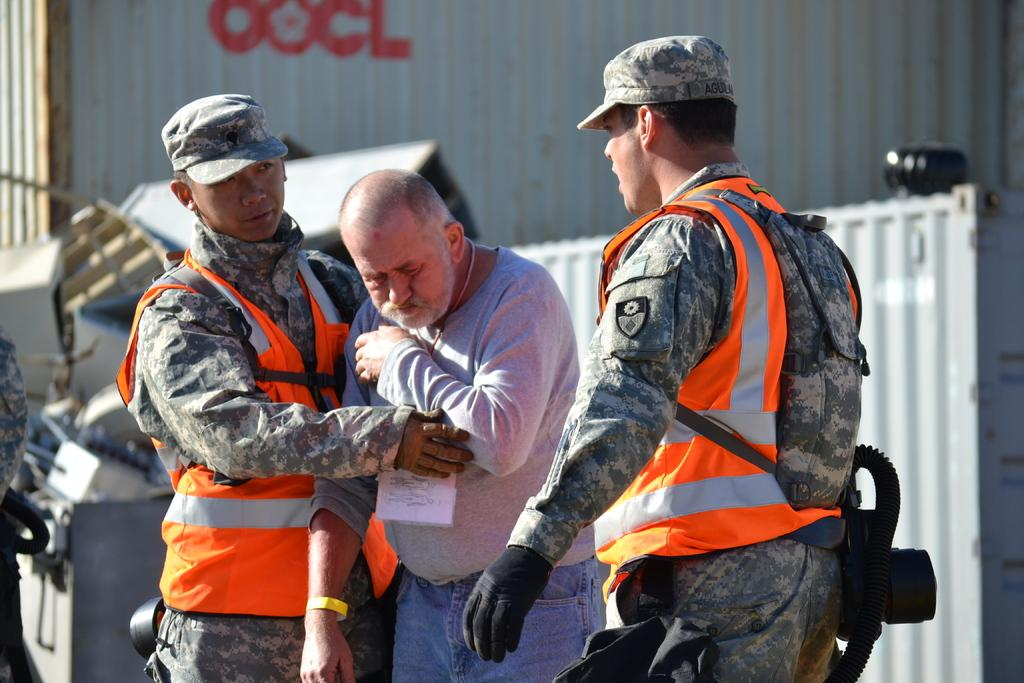How many men are in the foreground of the image? There are three men in the foreground of the image. What are two of the men wearing? Two of the men are wearing jackets. What can be seen in the background of the image? In the background, there are containers and a person on the left side. How many objects are visible in the background? There are few objects visible in the background. What type of key is being used to unlock the jam in the image? There is no key or jam present in the image. What company is responsible for the containers in the background? The image does not provide information about the company responsible for the containers in the background. 